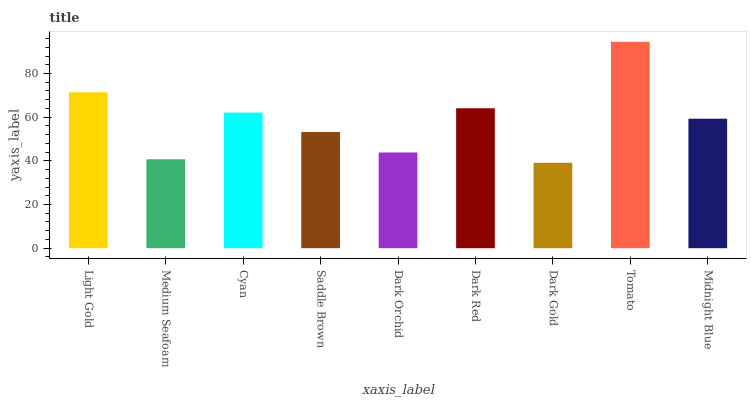Is Dark Gold the minimum?
Answer yes or no. Yes. Is Tomato the maximum?
Answer yes or no. Yes. Is Medium Seafoam the minimum?
Answer yes or no. No. Is Medium Seafoam the maximum?
Answer yes or no. No. Is Light Gold greater than Medium Seafoam?
Answer yes or no. Yes. Is Medium Seafoam less than Light Gold?
Answer yes or no. Yes. Is Medium Seafoam greater than Light Gold?
Answer yes or no. No. Is Light Gold less than Medium Seafoam?
Answer yes or no. No. Is Midnight Blue the high median?
Answer yes or no. Yes. Is Midnight Blue the low median?
Answer yes or no. Yes. Is Tomato the high median?
Answer yes or no. No. Is Light Gold the low median?
Answer yes or no. No. 